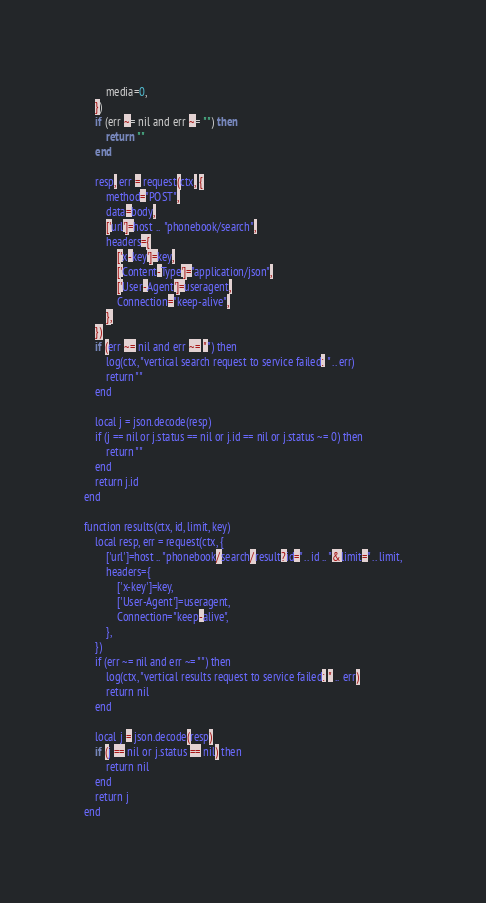<code> <loc_0><loc_0><loc_500><loc_500><_Ada_>        media=0,
    })
    if (err ~= nil and err ~= "") then
        return ""
    end

    resp, err = request(ctx, {
        method="POST",
        data=body,
        ['url']=host .. "phonebook/search",
        headers={
            ['x-key']=key,
            ['Content-Type']="application/json",
            ['User-Agent']=useragent,
            Connection="keep-alive",
        },
    })
    if (err ~= nil and err ~= "") then
        log(ctx, "vertical search request to service failed: " .. err)
        return ""
    end

    local j = json.decode(resp)
    if (j == nil or j.status == nil or j.id == nil or j.status ~= 0) then
        return ""
    end
    return j.id
end

function results(ctx, id, limit, key)
    local resp, err = request(ctx, {
        ['url']=host .. "phonebook/search/result?id=" .. id .. "&limit=" .. limit,
        headers={
            ['x-key']=key,
            ['User-Agent']=useragent,
            Connection="keep-alive",
        },
    })
    if (err ~= nil and err ~= "") then
        log(ctx, "vertical results request to service failed: " .. err)
        return nil
    end

    local j = json.decode(resp)
    if (j == nil or j.status == nil) then
        return nil
    end
    return j
end
</code> 